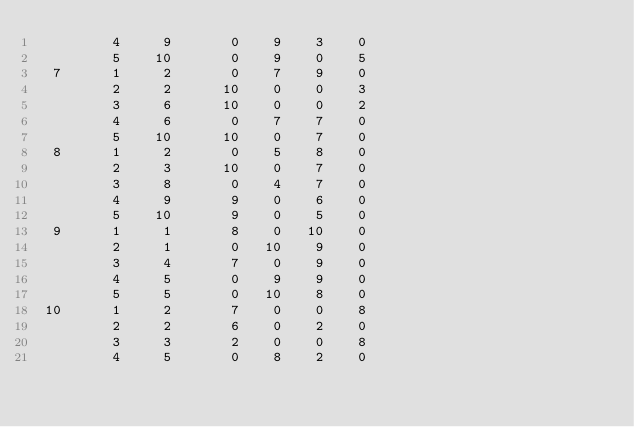Convert code to text. <code><loc_0><loc_0><loc_500><loc_500><_ObjectiveC_>         4     9       0    9    3    0
         5    10       0    9    0    5
  7      1     2       0    7    9    0
         2     2      10    0    0    3
         3     6      10    0    0    2
         4     6       0    7    7    0
         5    10      10    0    7    0
  8      1     2       0    5    8    0
         2     3      10    0    7    0
         3     8       0    4    7    0
         4     9       9    0    6    0
         5    10       9    0    5    0
  9      1     1       8    0   10    0
         2     1       0   10    9    0
         3     4       7    0    9    0
         4     5       0    9    9    0
         5     5       0   10    8    0
 10      1     2       7    0    0    8
         2     2       6    0    2    0
         3     3       2    0    0    8
         4     5       0    8    2    0</code> 